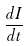<formula> <loc_0><loc_0><loc_500><loc_500>\frac { d I } { d t }</formula> 